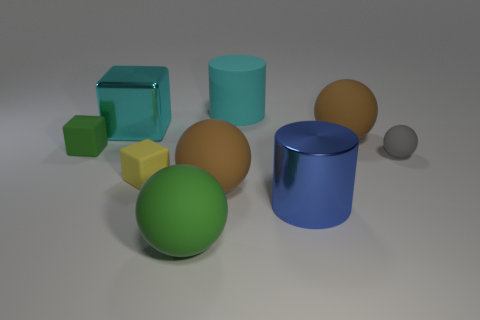Subtract all green blocks. Subtract all red cylinders. How many blocks are left? 2 Add 1 small metallic cylinders. How many objects exist? 10 Subtract all blocks. How many objects are left? 6 Subtract 0 cyan spheres. How many objects are left? 9 Subtract all rubber things. Subtract all tiny rubber cubes. How many objects are left? 0 Add 5 large blue metallic cylinders. How many large blue metallic cylinders are left? 6 Add 1 tiny things. How many tiny things exist? 4 